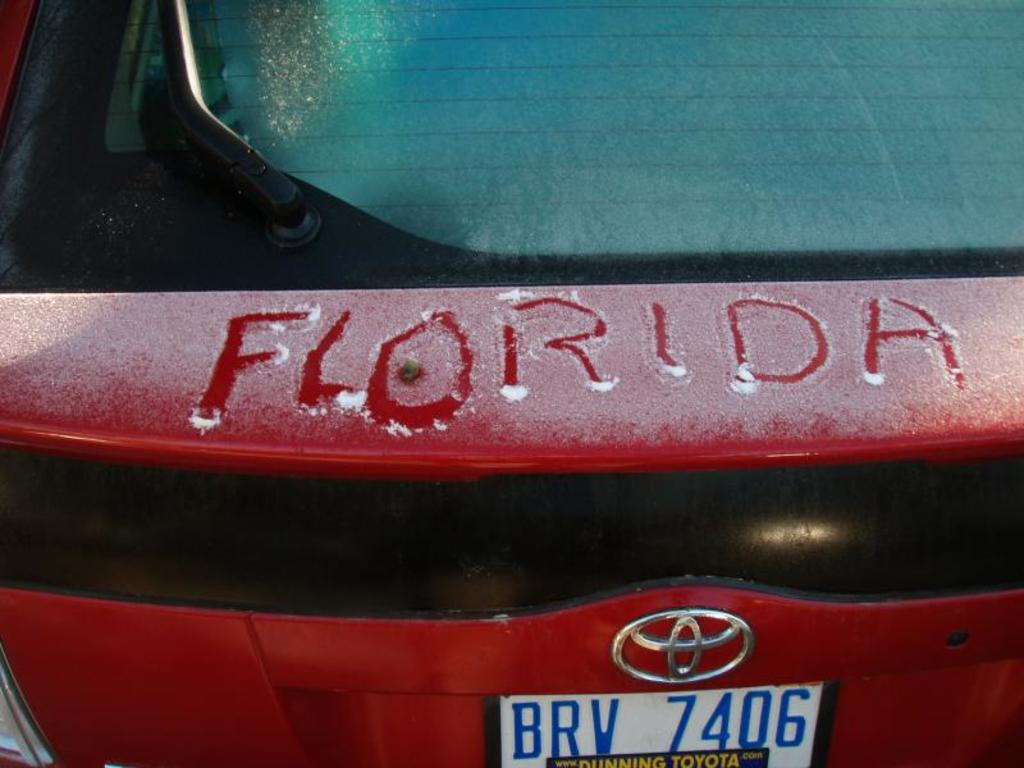What might the person who wrote 'Florida' on the car be feeling? The person who wrote 'Florida' on the snowy surface of this car might be feeling nostalgic or whimsical about warmer climates. This playful gesture suggests a longing for the sunny beaches and mild temperatures of Florida, contrasting sharply with the current cold surroundings. 